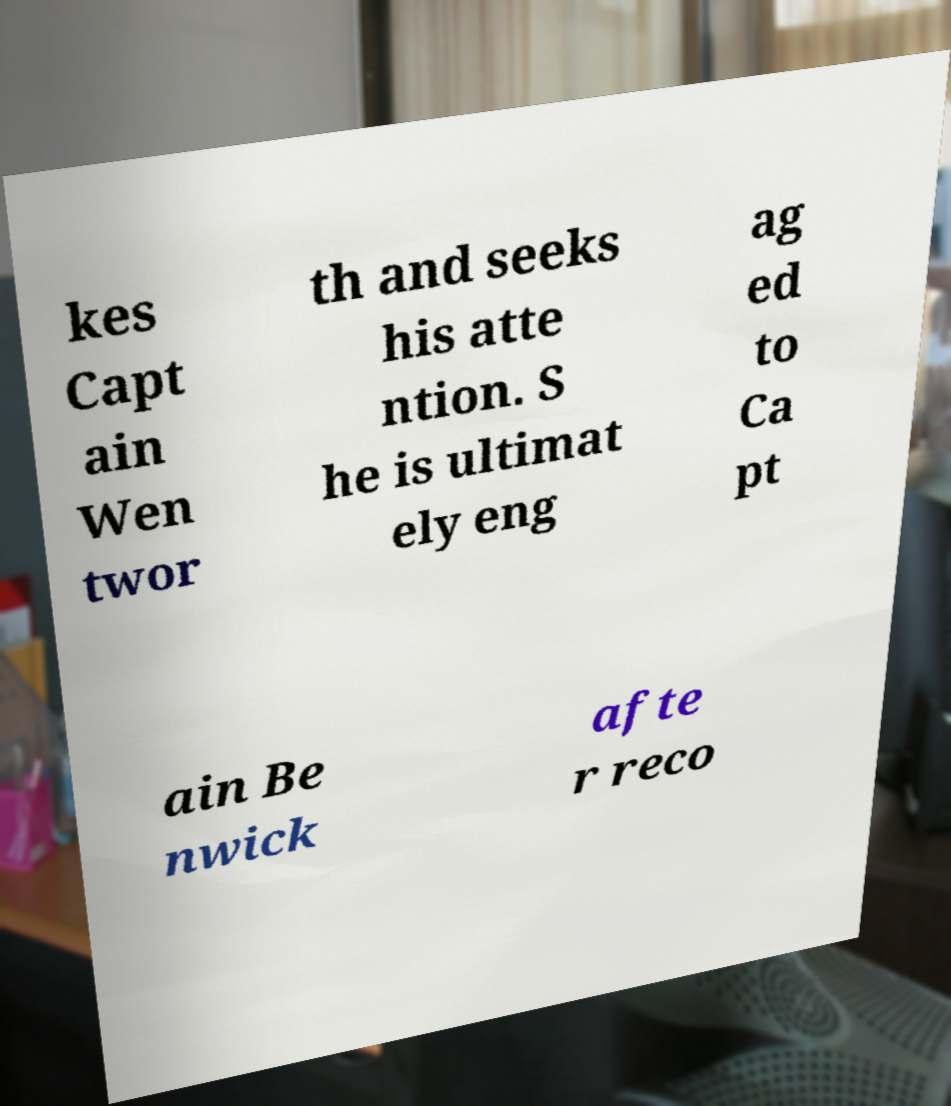For documentation purposes, I need the text within this image transcribed. Could you provide that? kes Capt ain Wen twor th and seeks his atte ntion. S he is ultimat ely eng ag ed to Ca pt ain Be nwick afte r reco 